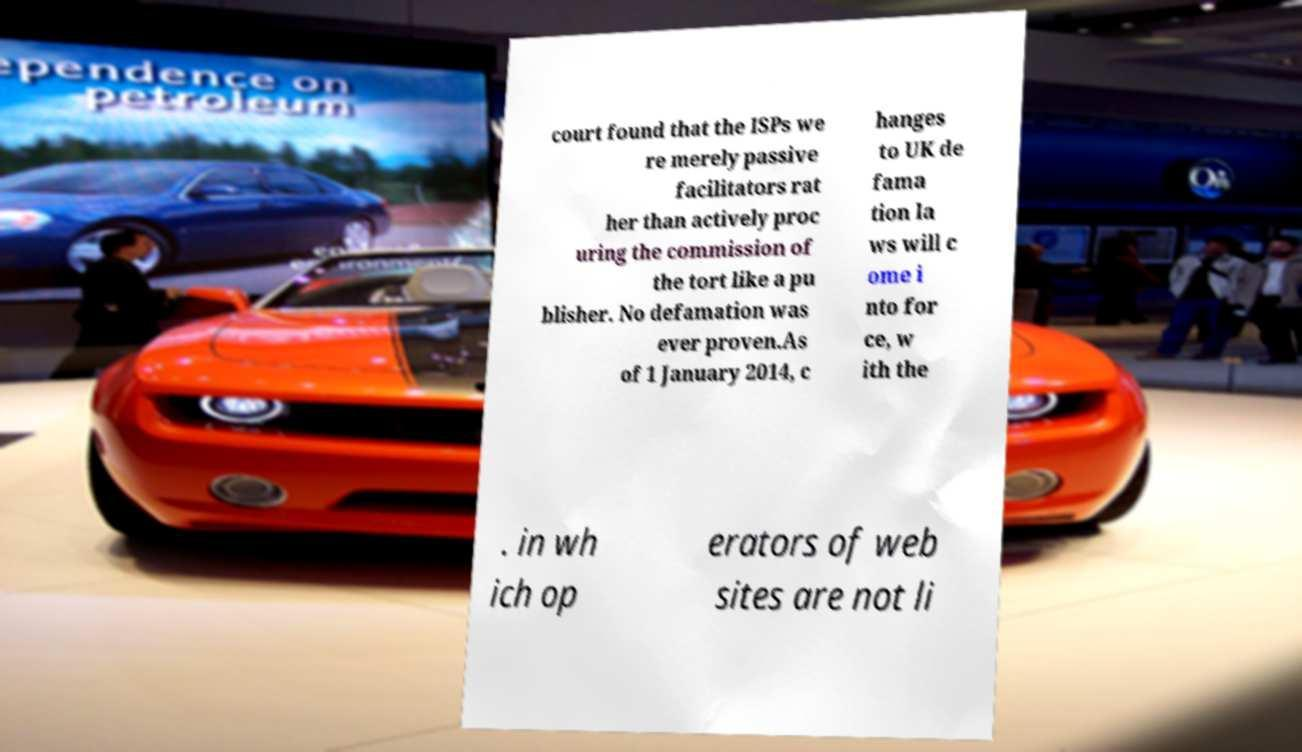Can you accurately transcribe the text from the provided image for me? court found that the ISPs we re merely passive facilitators rat her than actively proc uring the commission of the tort like a pu blisher. No defamation was ever proven.As of 1 January 2014, c hanges to UK de fama tion la ws will c ome i nto for ce, w ith the . in wh ich op erators of web sites are not li 